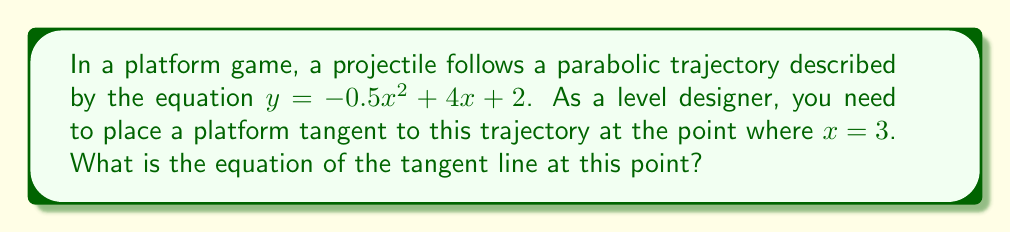Help me with this question. To find the equation of the tangent line, we'll follow these steps:

1) The general form of a parabola is $y = ax^2 + bx + c$. In this case:
   $a = -0.5$, $b = 4$, and $c = 2$

2) The derivative of the parabola gives us the slope of the tangent line at any point:
   $$\frac{dy}{dx} = 2ax + b = -x + 4$$

3) At $x = 3$, the slope of the tangent line is:
   $$\frac{dy}{dx}|_{x=3} = -(3) + 4 = 1$$

4) To find the y-coordinate of the point of tangency, we substitute $x = 3$ into the original equation:
   $$y = -0.5(3)^2 + 4(3) + 2 = -4.5 + 12 + 2 = 9.5$$

5) Now we have a point $(3, 9.5)$ and a slope of 1. We can use the point-slope form of a line:
   $y - y_1 = m(x - x_1)$

6) Substituting our values:
   $y - 9.5 = 1(x - 3)$

7) Simplify to slope-intercept form:
   $y = x - 3 + 9.5$
   $y = x + 6.5$

This is the equation of the tangent line where the platform should be placed.
Answer: $y = x + 6.5$ 